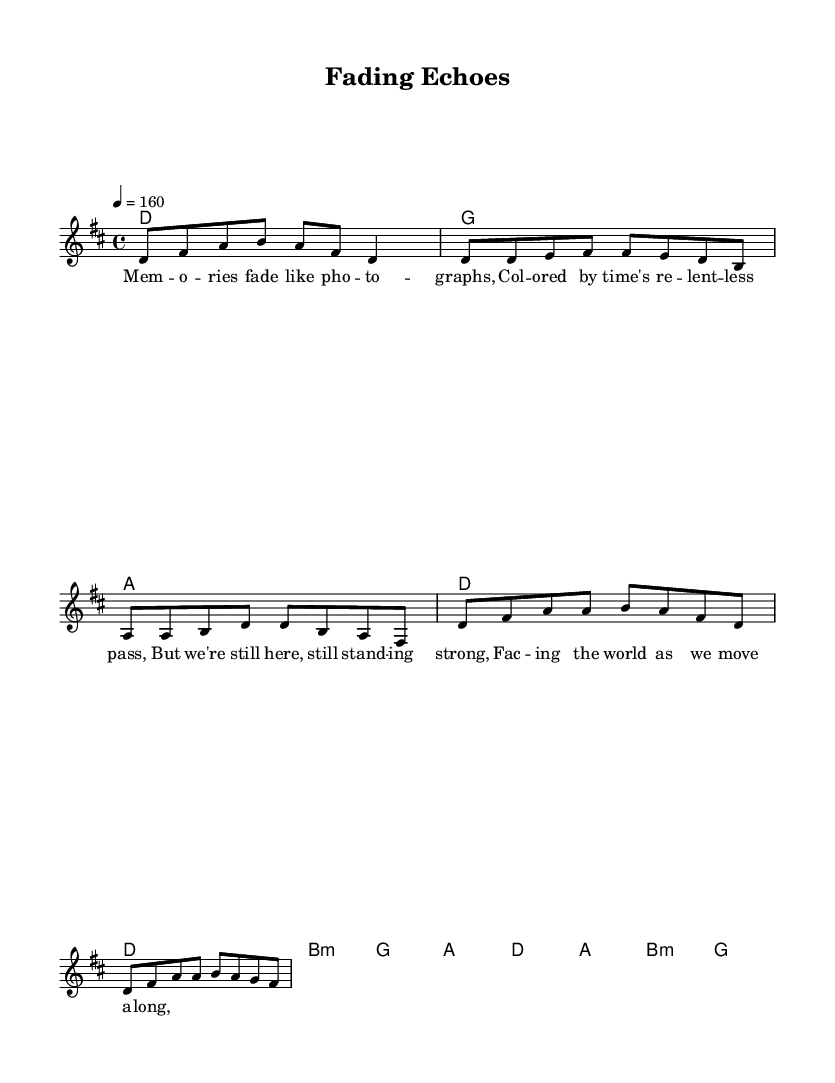What is the key signature of this music? The key signature is shown at the beginning of the staff. It has two sharps, indicating that the key is D major.
Answer: D major What is the time signature of this music? The time signature is indicated by the numbers at the beginning of the staff. It shows four beats per measure, which is 4/4.
Answer: 4/4 What is the tempo marking of this piece? The tempo marking is provided in beats per minute, indicated by "4 = 160." This means there are 160 quarter note beats per minute.
Answer: 160 What is the first line of the verse lyrics? The lyrics are shown underneath the melody. The first line of the verse is "Memories fade like photographs."
Answer: Memories fade like photographs How many measures are in the chorus? The chorus section consists of two measures. Each line in the music corresponds to a measure, with the lyrics laid beneath it.
Answer: 2 What is the primary chord progression used throughout the piece? The chord progression is listed under the chord names, with D, G, and A being the major chords primarily used. It features a variation with B minor in the second repetition.
Answer: D, G, A, B minor What writing technique is evident in the lyrics of this piece? The lyrics reflect introspective songwriting, focusing on personal feelings and experiences, which is a hallmark of melodic punk rock from the 1990s.
Answer: Introspective songwriting 